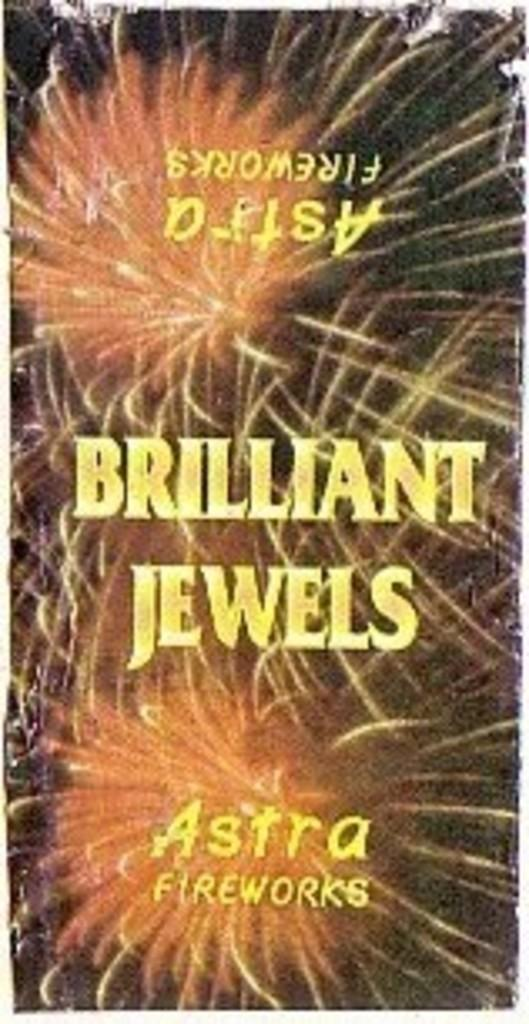<image>
Offer a succinct explanation of the picture presented. Fireworks are seen behind the words Brilliant Jewels. 